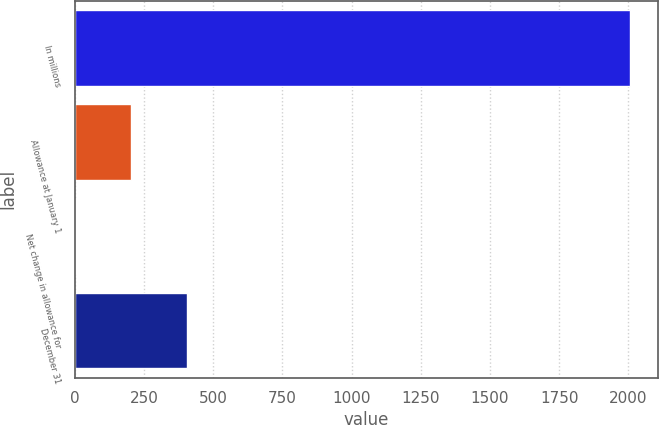Convert chart to OTSL. <chart><loc_0><loc_0><loc_500><loc_500><bar_chart><fcel>In millions<fcel>Allowance at January 1<fcel>Net change in allowance for<fcel>December 31<nl><fcel>2007<fcel>203.4<fcel>3<fcel>403.8<nl></chart> 